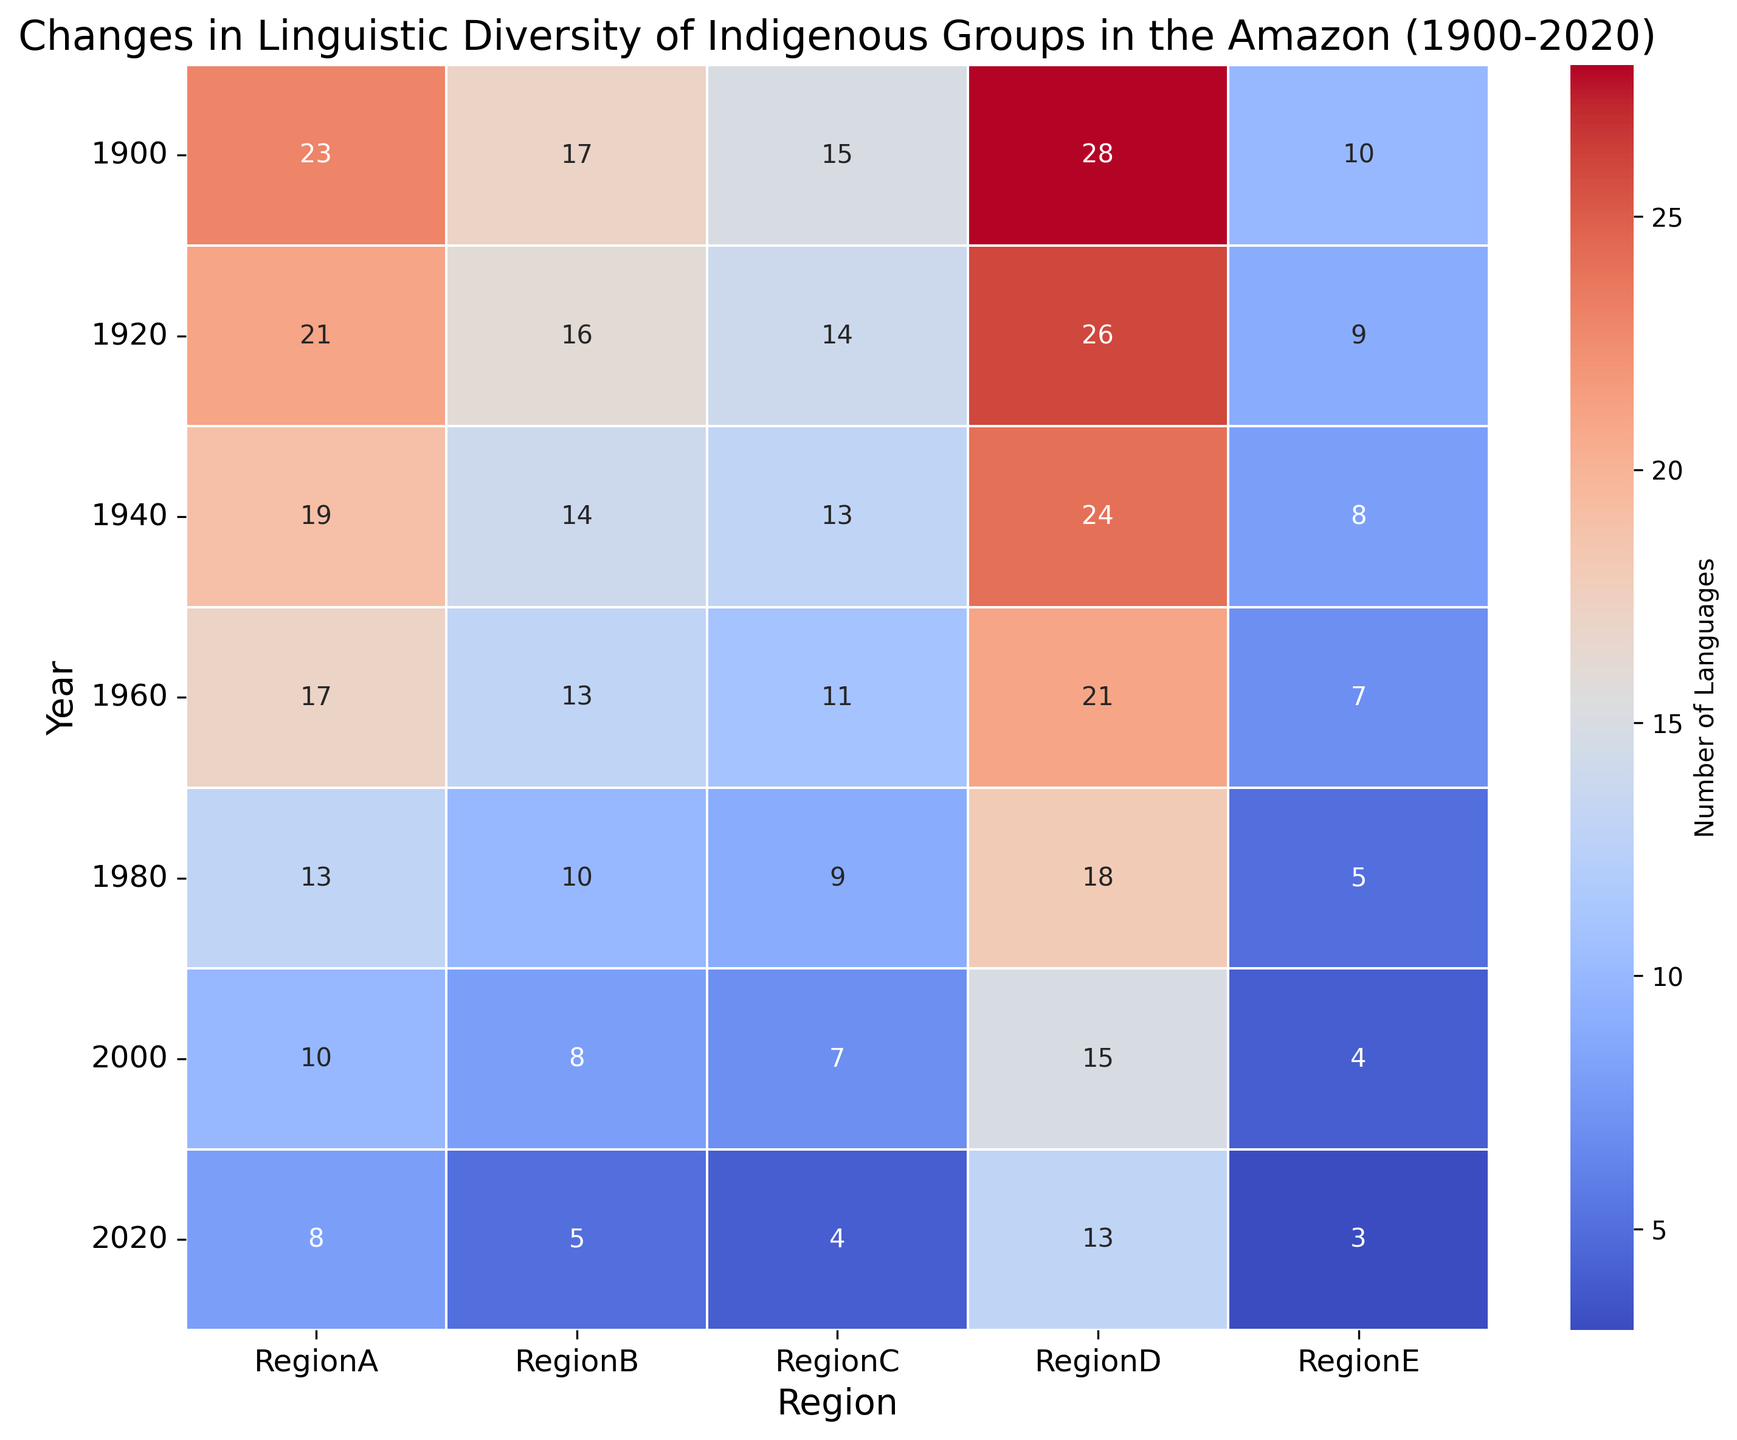What year did Region A experience the highest linguistic diversity? We can identify the year with the highest linguistic diversity for Region A by looking at the highest number in the Region A column. The highest number is 23 in the year 1900.
Answer: 1900 Which region had the least number of languages in 1980? By examining the row for 1980, we compare the numbers across all regions. Region E has the smallest value, which is 5.
Answer: Region E By how much did the number of languages in Region D decrease from 1900 to 2020? Subtract the number of languages in Region D in 2020 from the number in 1900. The values are 28 (in 1900) and 13 (in 2020), so the difference is 28 - 13.
Answer: 15 In which decade did Region B see the largest decrease in the number of languages? Calculate the decrease for each decade by comparing subsequent years. The largest single decrease in Region B is seen between 1940 (14) and 1960 (13), which is a drop of 3.
Answer: 1940 to 1960 Which year shows the greatest variety in linguistic diversity across all regions? Look for the year with the greatest range between the highest and lowest values across all regions. In 1900, the range is the difference between the highest (28, Region D) and lowest (10, Region E), which is 28 - 10 = 18.
Answer: 1900 What was the average number of languages in Region C over the entire period? Add up the number of languages in Region C across all years and divide by the number of data points (7). The sum is 15 + 14 + 13 + 11 + 9 + 7 + 4 = 73, and the average is 73/7.
Answer: 10.43 Which region shows the most consistent decline in the number of languages over time? Identify the region with a continuous decline in numbers across all years. Region A's number of languages consistently decreases: 23 (1900), 21 (1920), 19 (1940), 17 (1960), 13 (1980), 10 (2000), 8 (2020).
Answer: Region A Between 1900 and 2000, which region experienced the smallest reduction in the number of languages? Calculate the reduction for each region from 1900 to 2000 and identify the smallest value. Region D decreases from 28 (1900) to 15 (2000), a reduction of 13.
Answer: Region D 